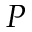Convert formula to latex. <formula><loc_0><loc_0><loc_500><loc_500>P</formula> 